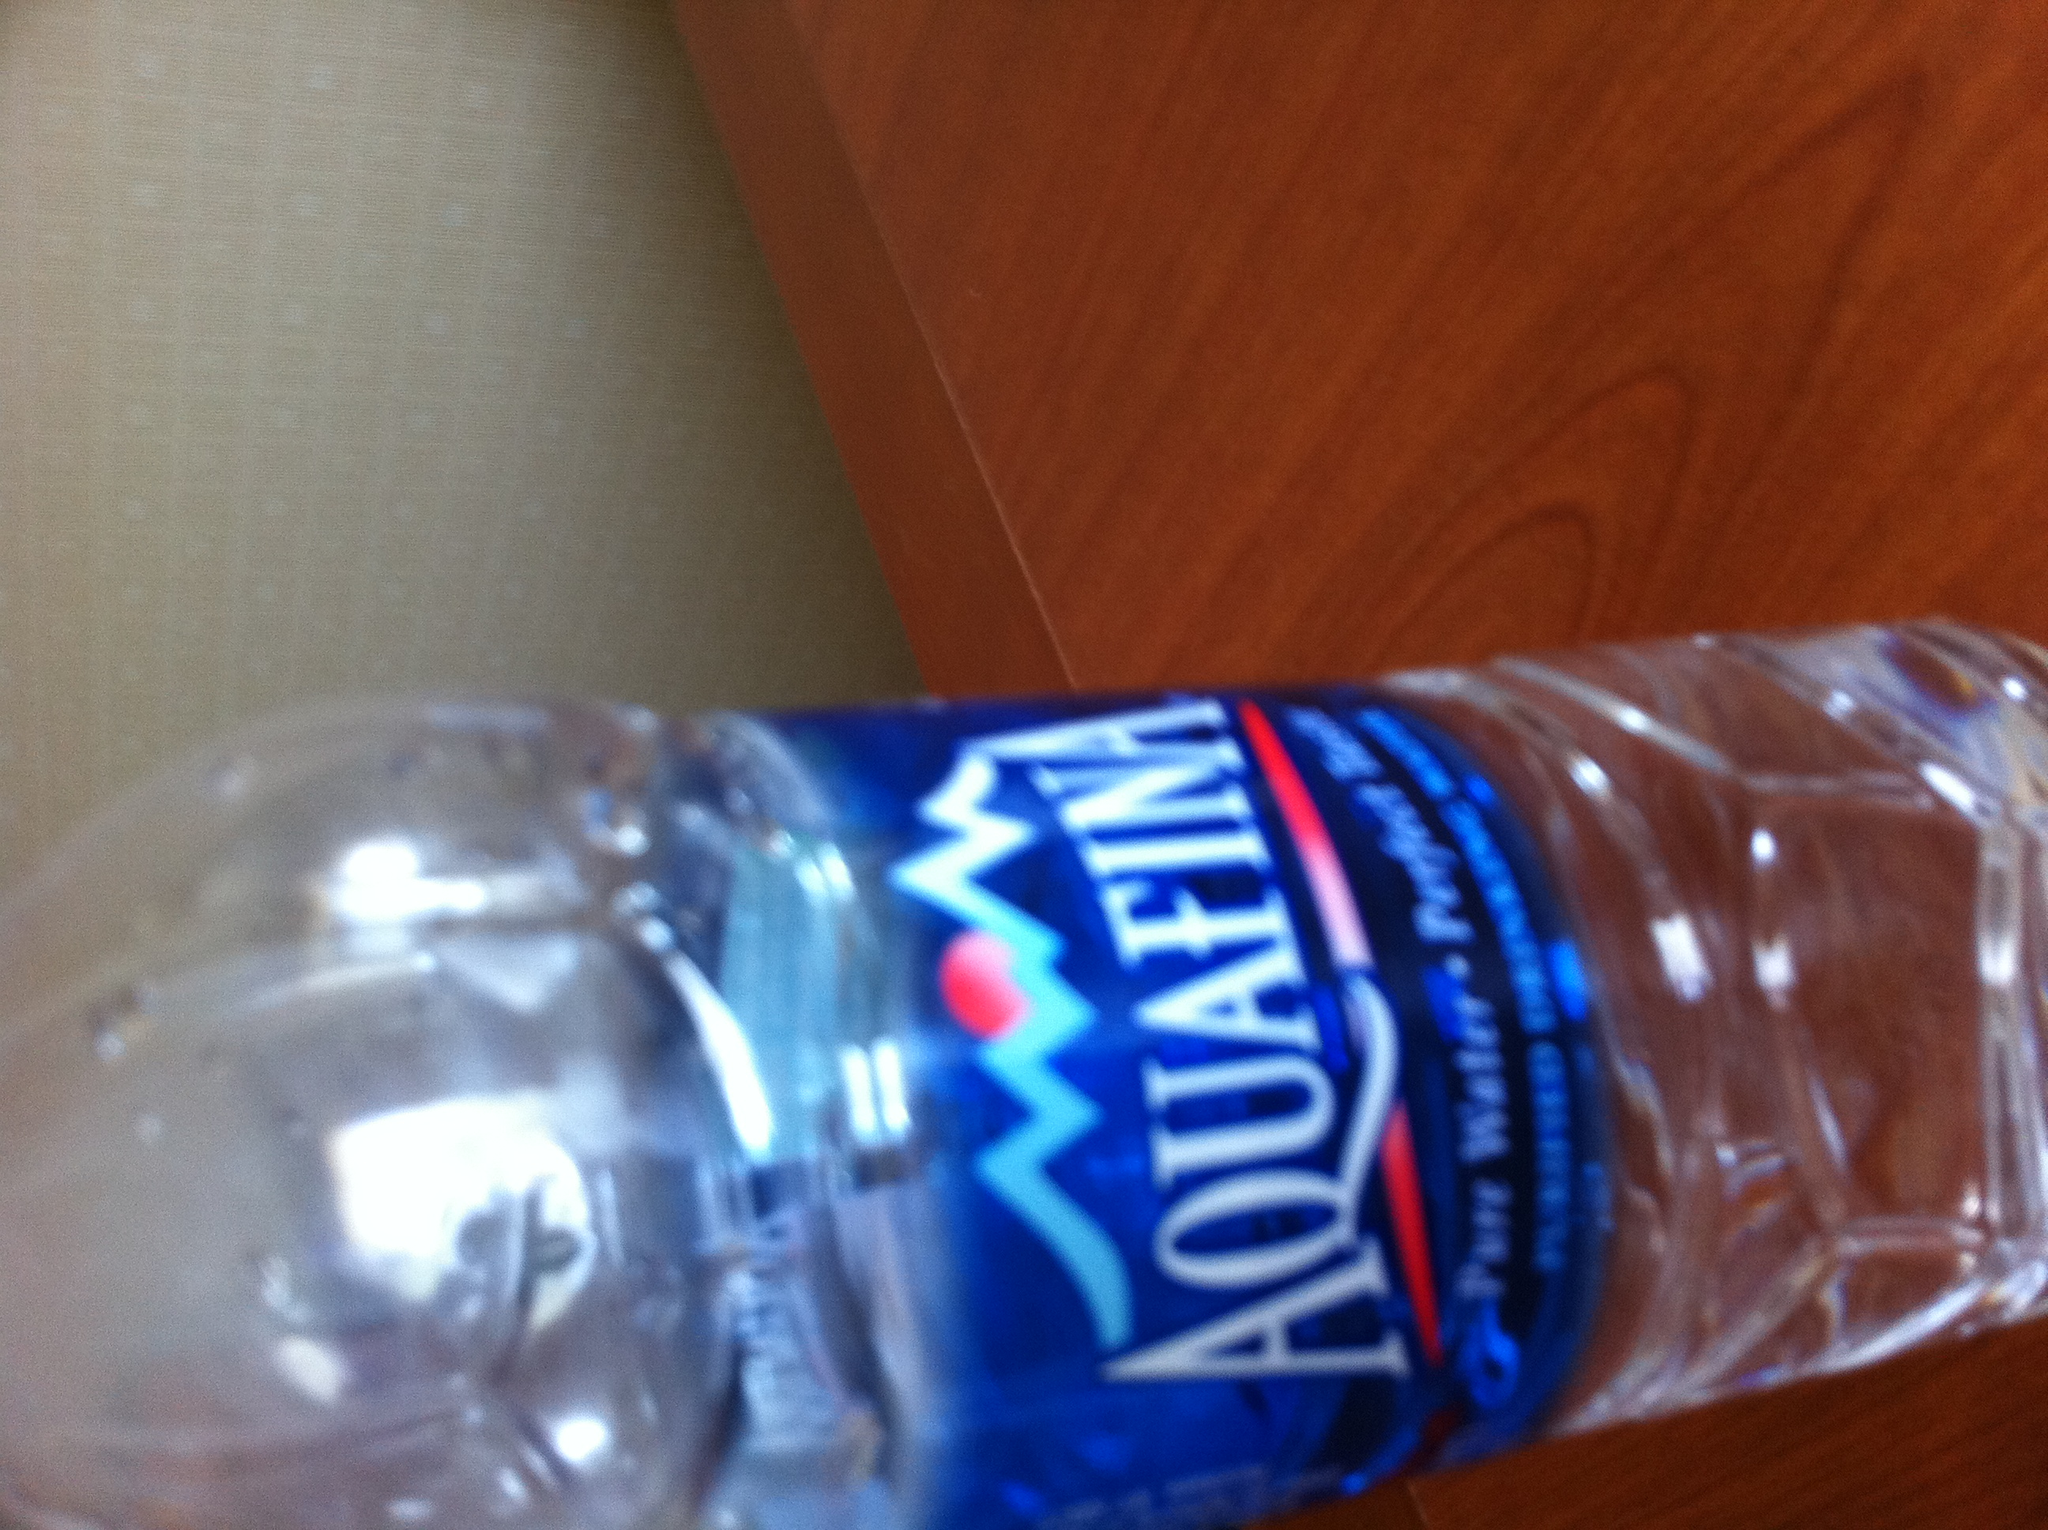What kind of water is this? from Vizwiz aquafina 